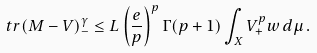Convert formula to latex. <formula><loc_0><loc_0><loc_500><loc_500>\ t r ( M - V ) _ { - } ^ { \gamma } \leq L \left ( \frac { e } { p } \right ) ^ { p } \Gamma ( p + 1 ) \int _ { X } V _ { + } ^ { p } w \, d \mu \, .</formula> 